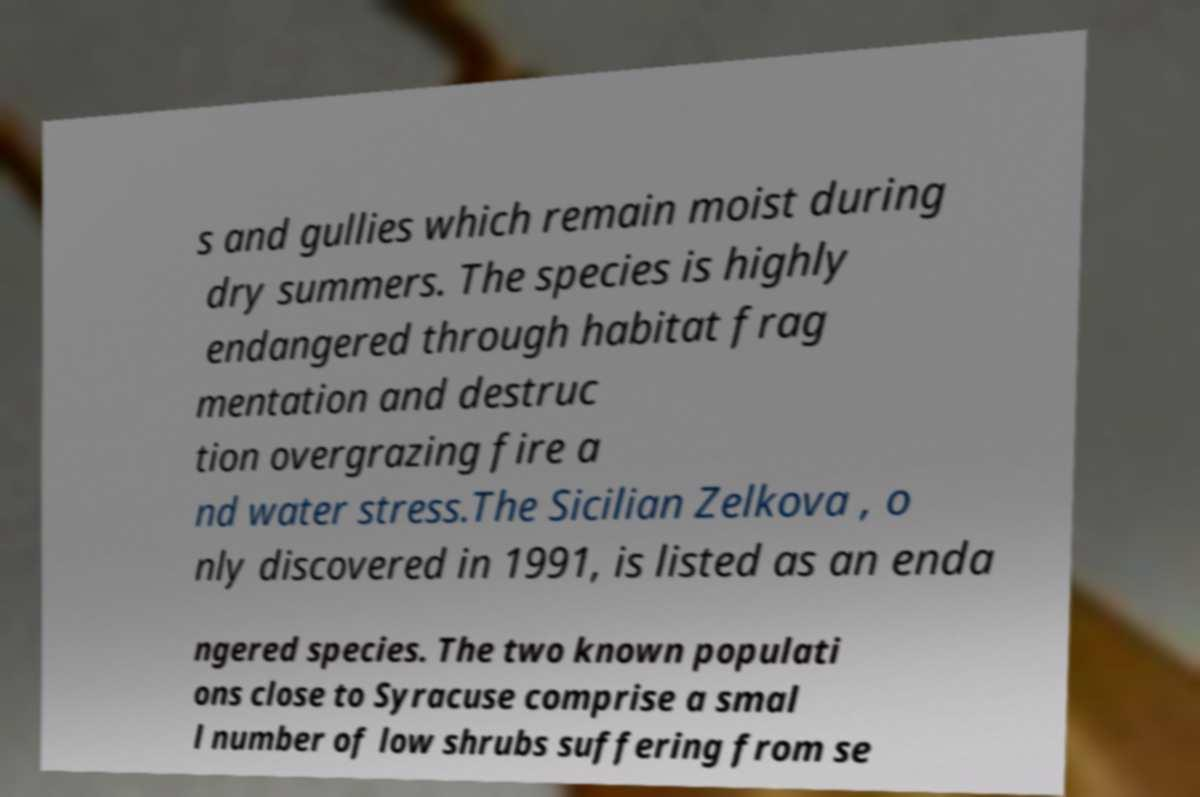What messages or text are displayed in this image? I need them in a readable, typed format. s and gullies which remain moist during dry summers. The species is highly endangered through habitat frag mentation and destruc tion overgrazing fire a nd water stress.The Sicilian Zelkova , o nly discovered in 1991, is listed as an enda ngered species. The two known populati ons close to Syracuse comprise a smal l number of low shrubs suffering from se 